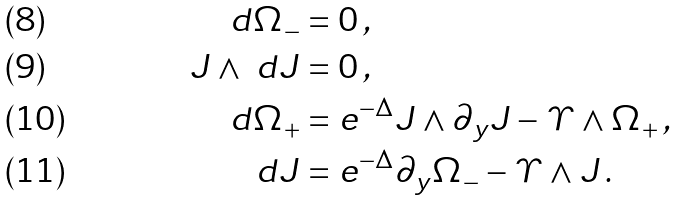<formula> <loc_0><loc_0><loc_500><loc_500>d \Omega _ { - } & = 0 \, , \\ J \wedge \ d J & = 0 \, , \\ d \Omega _ { + } & = e ^ { - \Delta } J \wedge \partial _ { y } J - \varUpsilon \wedge \Omega _ { + } \, , \\ d J & = e ^ { - \Delta } \partial _ { y } \Omega _ { - } - \varUpsilon \wedge J \, .</formula> 